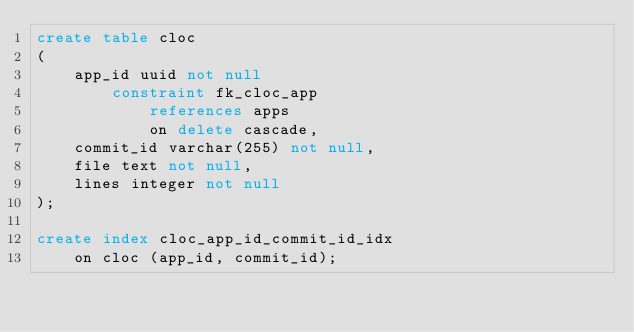Convert code to text. <code><loc_0><loc_0><loc_500><loc_500><_SQL_>create table cloc
(
    app_id uuid not null
        constraint fk_cloc_app
            references apps
            on delete cascade,
    commit_id varchar(255) not null,
    file text not null,
    lines integer not null
);

create index cloc_app_id_commit_id_idx
    on cloc (app_id, commit_id);</code> 